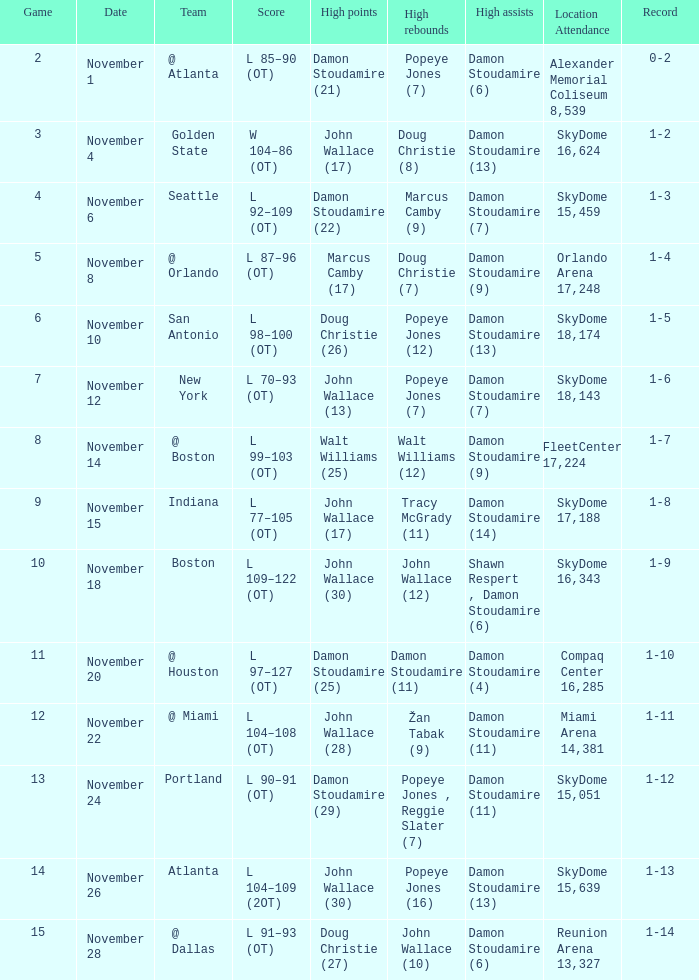How many games did the team play when they were 1-3? 1.0. 